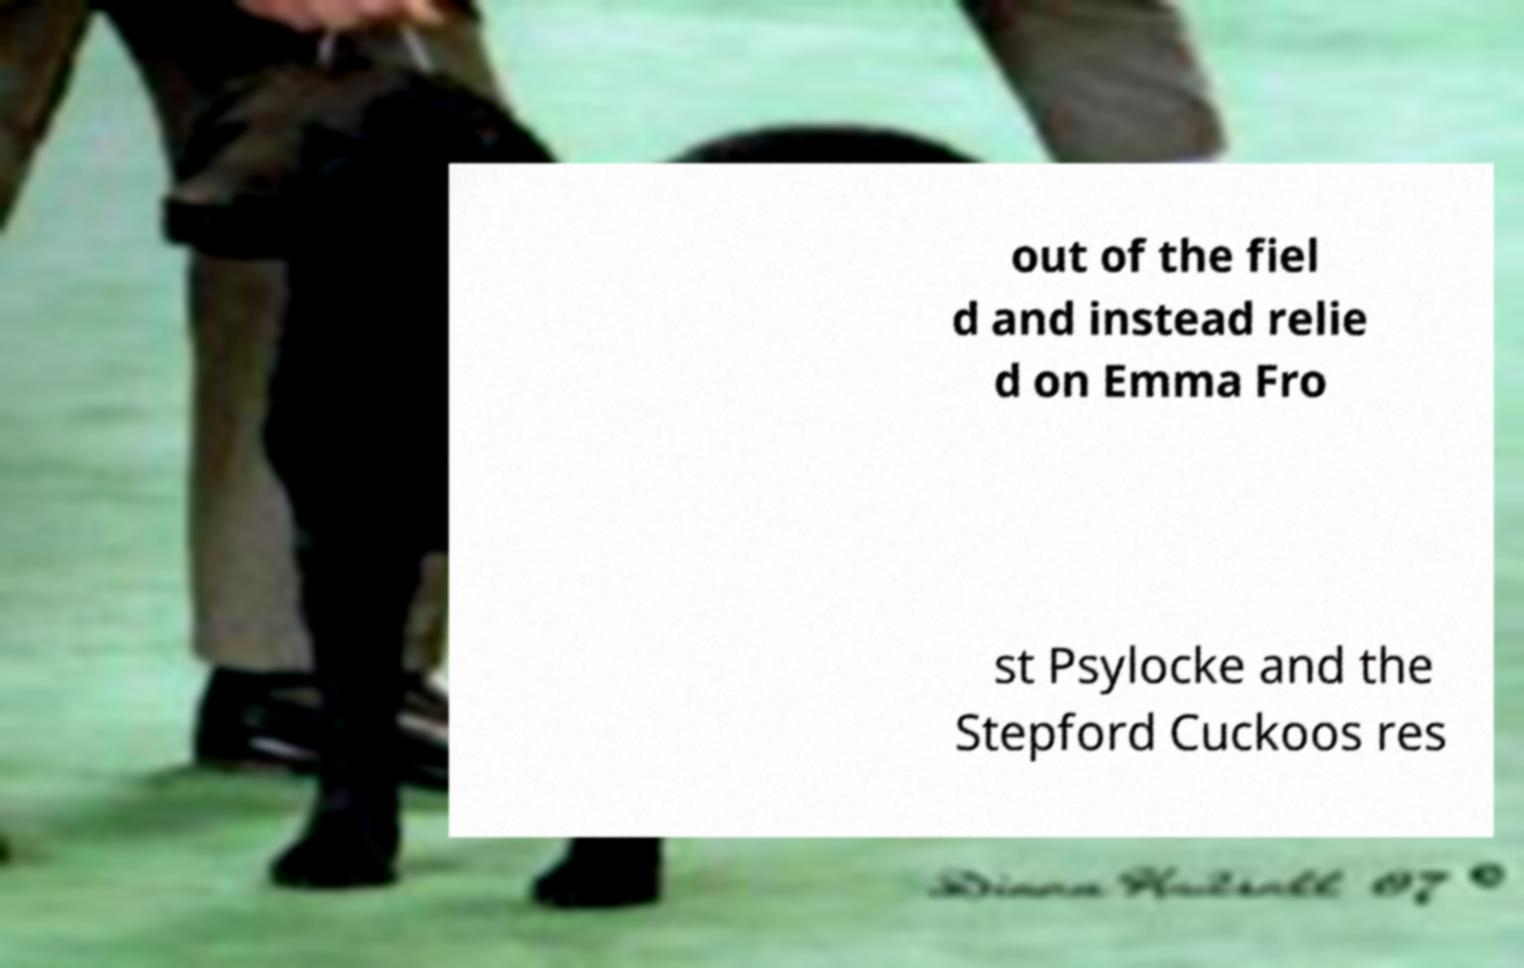What messages or text are displayed in this image? I need them in a readable, typed format. out of the fiel d and instead relie d on Emma Fro st Psylocke and the Stepford Cuckoos res 